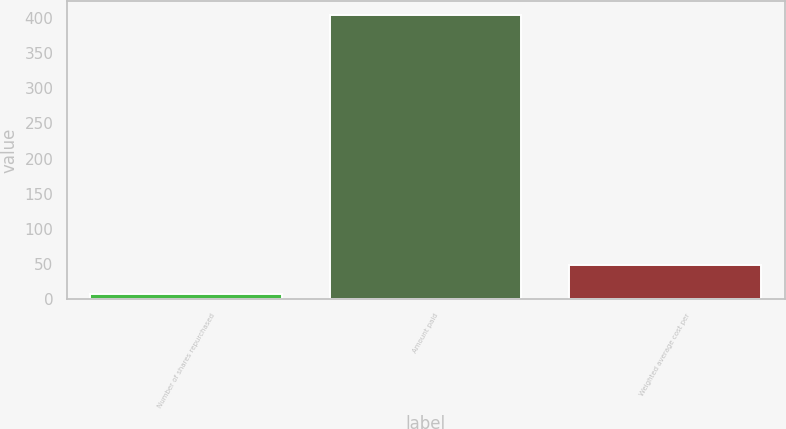<chart> <loc_0><loc_0><loc_500><loc_500><bar_chart><fcel>Number of shares repurchased<fcel>Amount paid<fcel>Weighted average cost per<nl><fcel>8.4<fcel>403.8<fcel>48.56<nl></chart> 